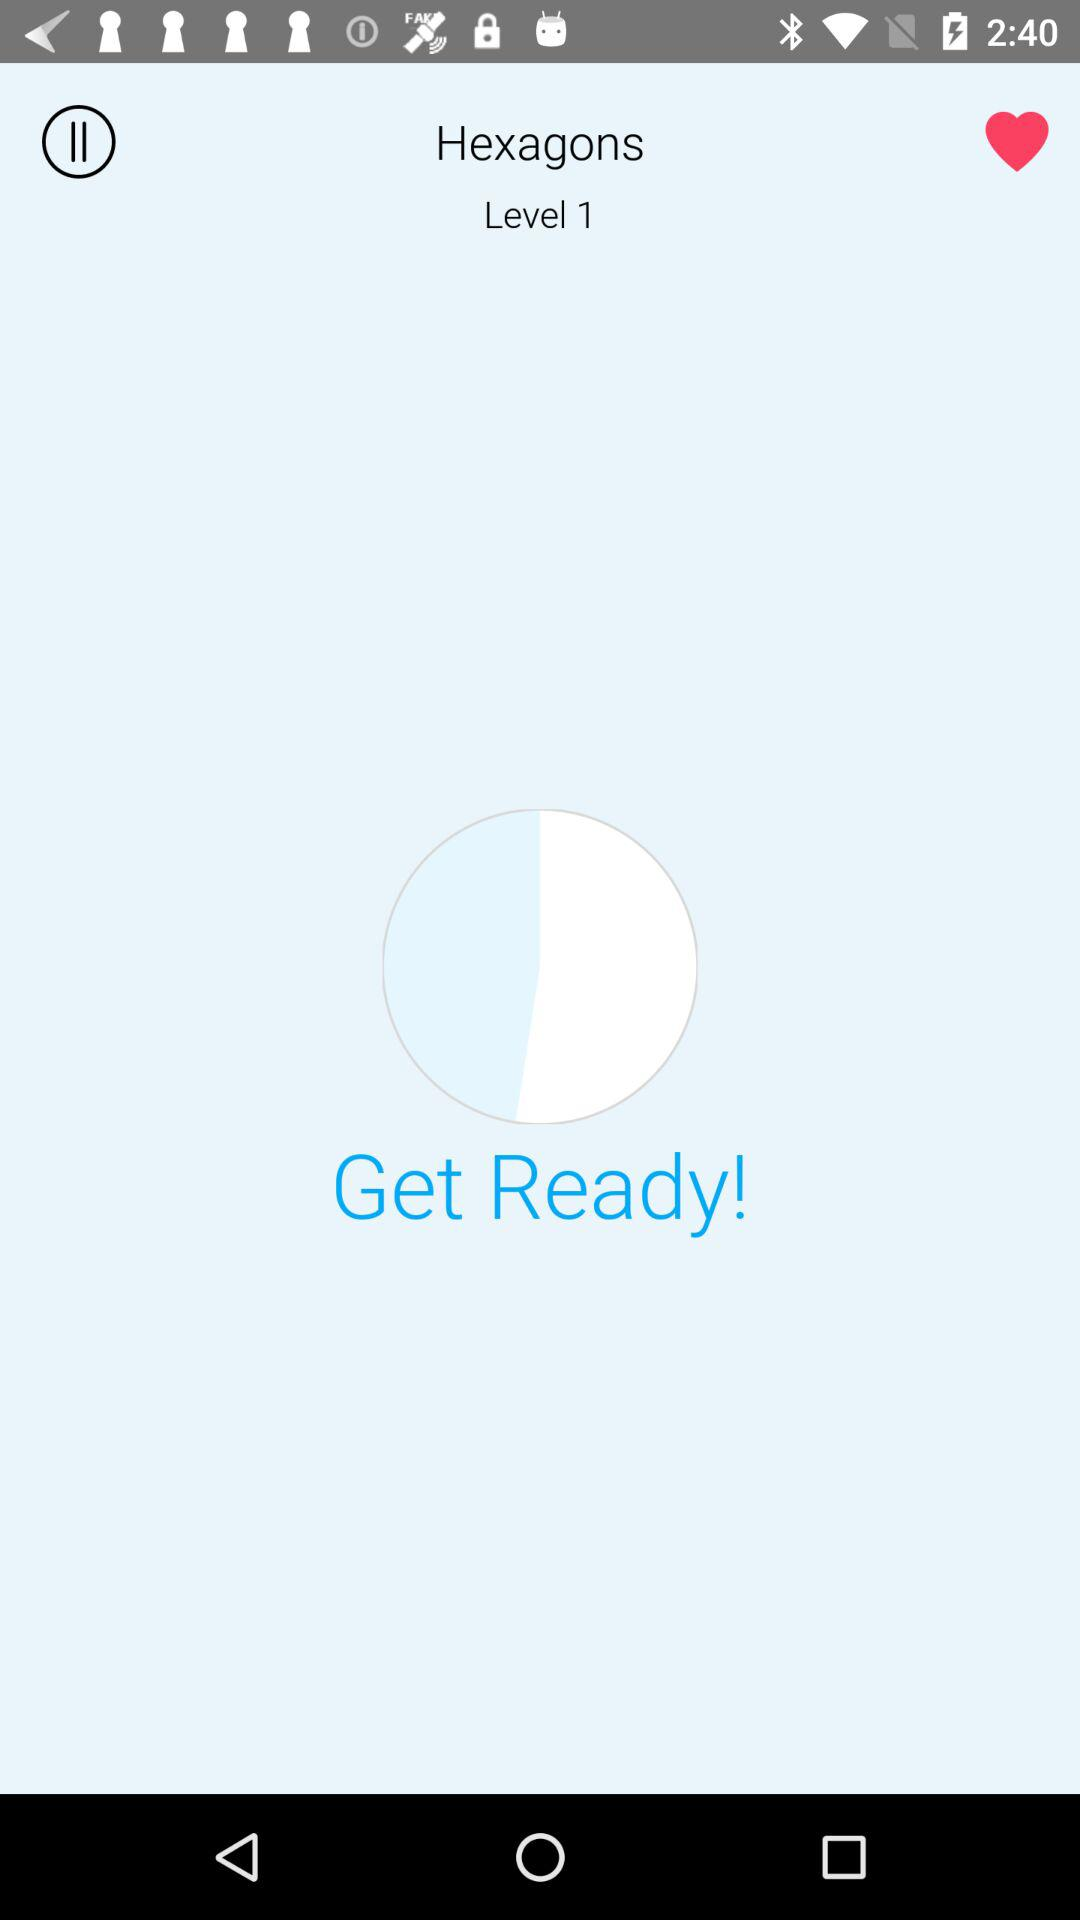What is the title given for Level 1? The given title for Level 1 is "Hexagons". 